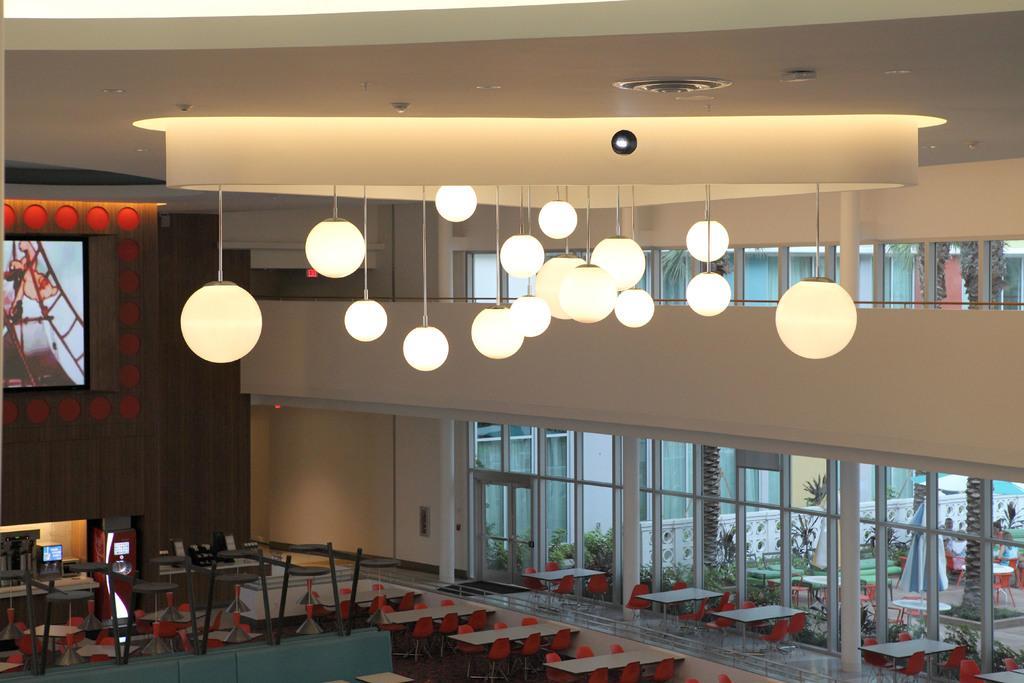Could you give a brief overview of what you see in this image? This image is taken indoors. At the top of the image there is a roof with many lights and lamps. At the bottom of the image there are many empty chairs and tables on the floor. In the background there are few walls. There is a screen on the wall. There are many glass doors. Through the glass doors we can see there are many plants in the pots. 